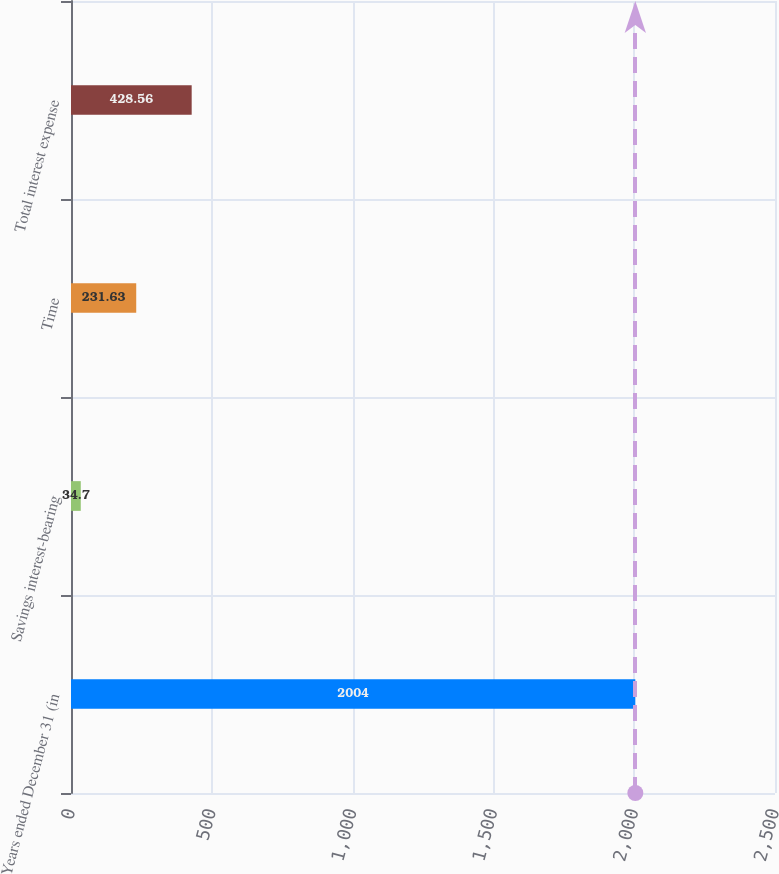Convert chart. <chart><loc_0><loc_0><loc_500><loc_500><bar_chart><fcel>Years ended December 31 (in<fcel>Savings interest-bearing<fcel>Time<fcel>Total interest expense<nl><fcel>2004<fcel>34.7<fcel>231.63<fcel>428.56<nl></chart> 